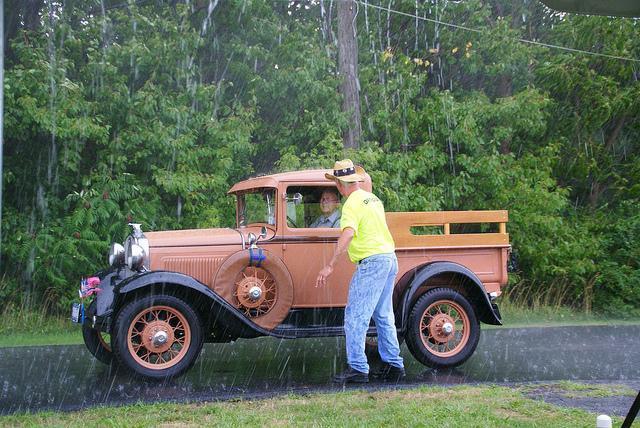How many people are in the picture?
Give a very brief answer. 2. How many wheels does this have?
Give a very brief answer. 4. 